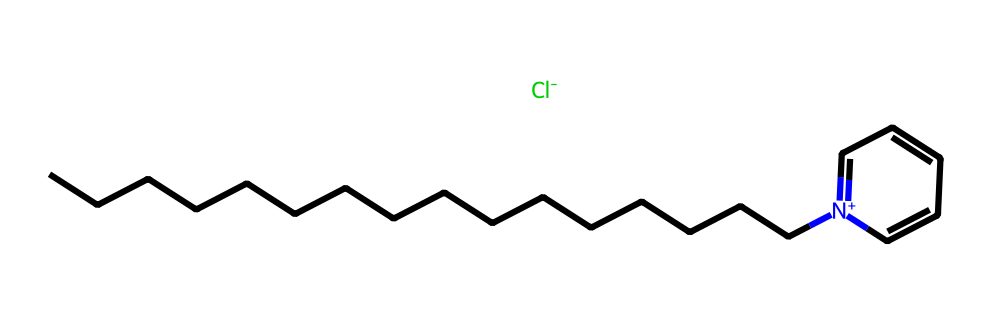What is the total number of carbon atoms in cetylpyridinium chloride? The SMILES representation shows a long aliphatic chain indicated by 'CCCCCCCCCCCCCCCC', which counts to 16 carbon atoms, plus one carbon in the pyridine ring (from 'N+1=CC=CC=C1'). Therefore, the total is 16 + 1 = 17 carbon atoms.
Answer: 17 How many nitrogen atoms are present in cetylpyridinium chloride? In the SMILES representation, there is one nitrogen indicated by 'N+'. Thus, there is one nitrogen atom in the structure.
Answer: 1 What type of functional group is present in cetylpyridinium chloride? The presence of a pyridine ring (as indicated by the structure 'N+1=CC=CC=C1') indicates that there is a heterocyclic amine functional group. This is a characteristic of the compound.
Answer: heterocyclic amine Does cetylpyridinium chloride have any halogen atoms? The presence of '[Cl-]' in the SMILES notation indicates the presence of one chlorine atom. Thus, there is one halogen atom.
Answer: 1 How many double bonds are in the pyridine ring of cetylpyridinium chloride? Analyzing the 'N+1=CC=CC=C1' segment, there are three double bonds (noted by the '=' symbols) in the pyridine ring.
Answer: 3 Is cetylpyridinium chloride a saturated or unsaturated compound? The presence of double bonds in the pyridine ring indicates that cetylpyridinium chloride is unsaturated. There are aliphatic saturated C-H bonds in the long chain, but the overall structure (including the ring) is classified as unsaturated.
Answer: unsaturated 